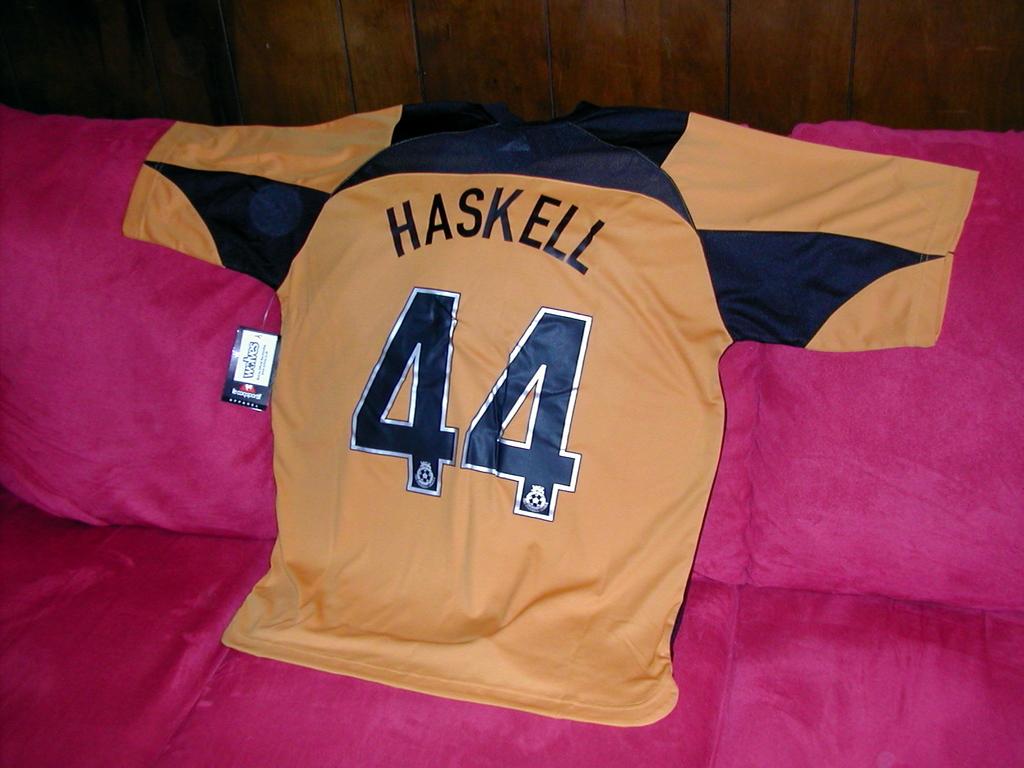What is player #44's name?
Give a very brief answer. Haskell. What number is pictured on the jersey?
Keep it short and to the point. 44. 